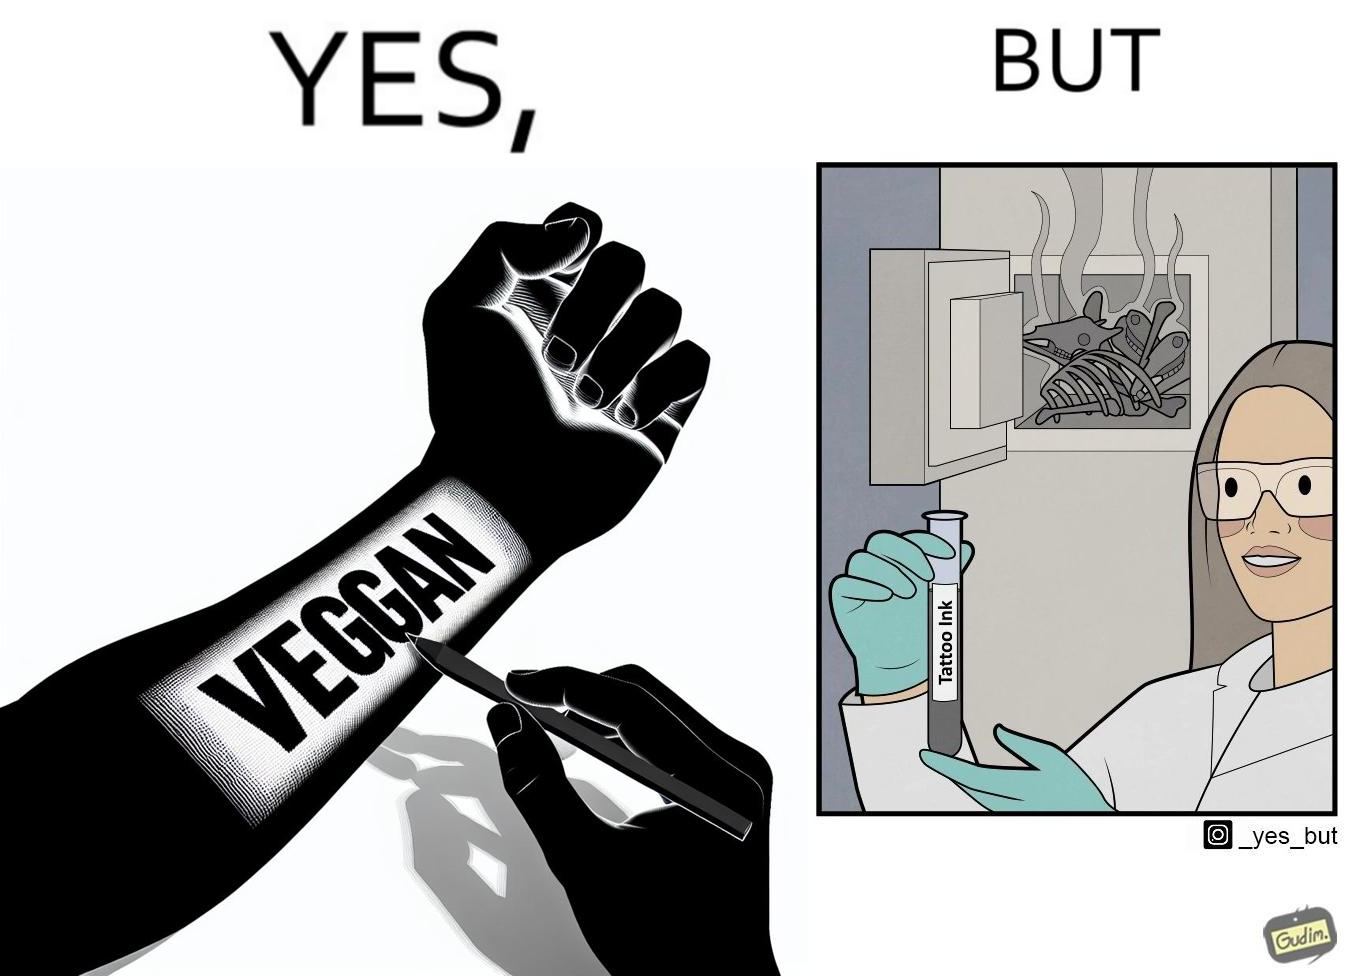Is there satirical content in this image? Yes, this image is satirical. 